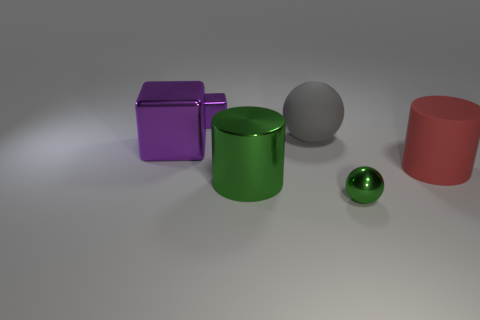There is a tiny thing that is in front of the green shiny cylinder; does it have the same shape as the gray rubber thing? Yes, the tiny object in front of the green shiny cylinder and the gray rubber object both share the same spherical shape, creating a visual harmony in this composition. 